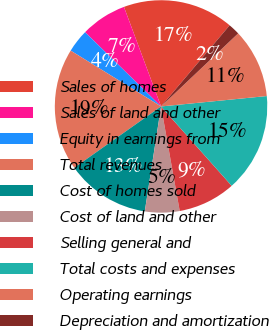<chart> <loc_0><loc_0><loc_500><loc_500><pie_chart><fcel>Sales of homes<fcel>Sales of land and other<fcel>Equity in earnings from<fcel>Total revenues<fcel>Cost of homes sold<fcel>Cost of land and other<fcel>Selling general and<fcel>Total costs and expenses<fcel>Operating earnings<fcel>Depreciation and amortization<nl><fcel>16.85%<fcel>7.01%<fcel>3.51%<fcel>18.6%<fcel>12.76%<fcel>5.26%<fcel>8.76%<fcel>14.99%<fcel>10.51%<fcel>1.76%<nl></chart> 